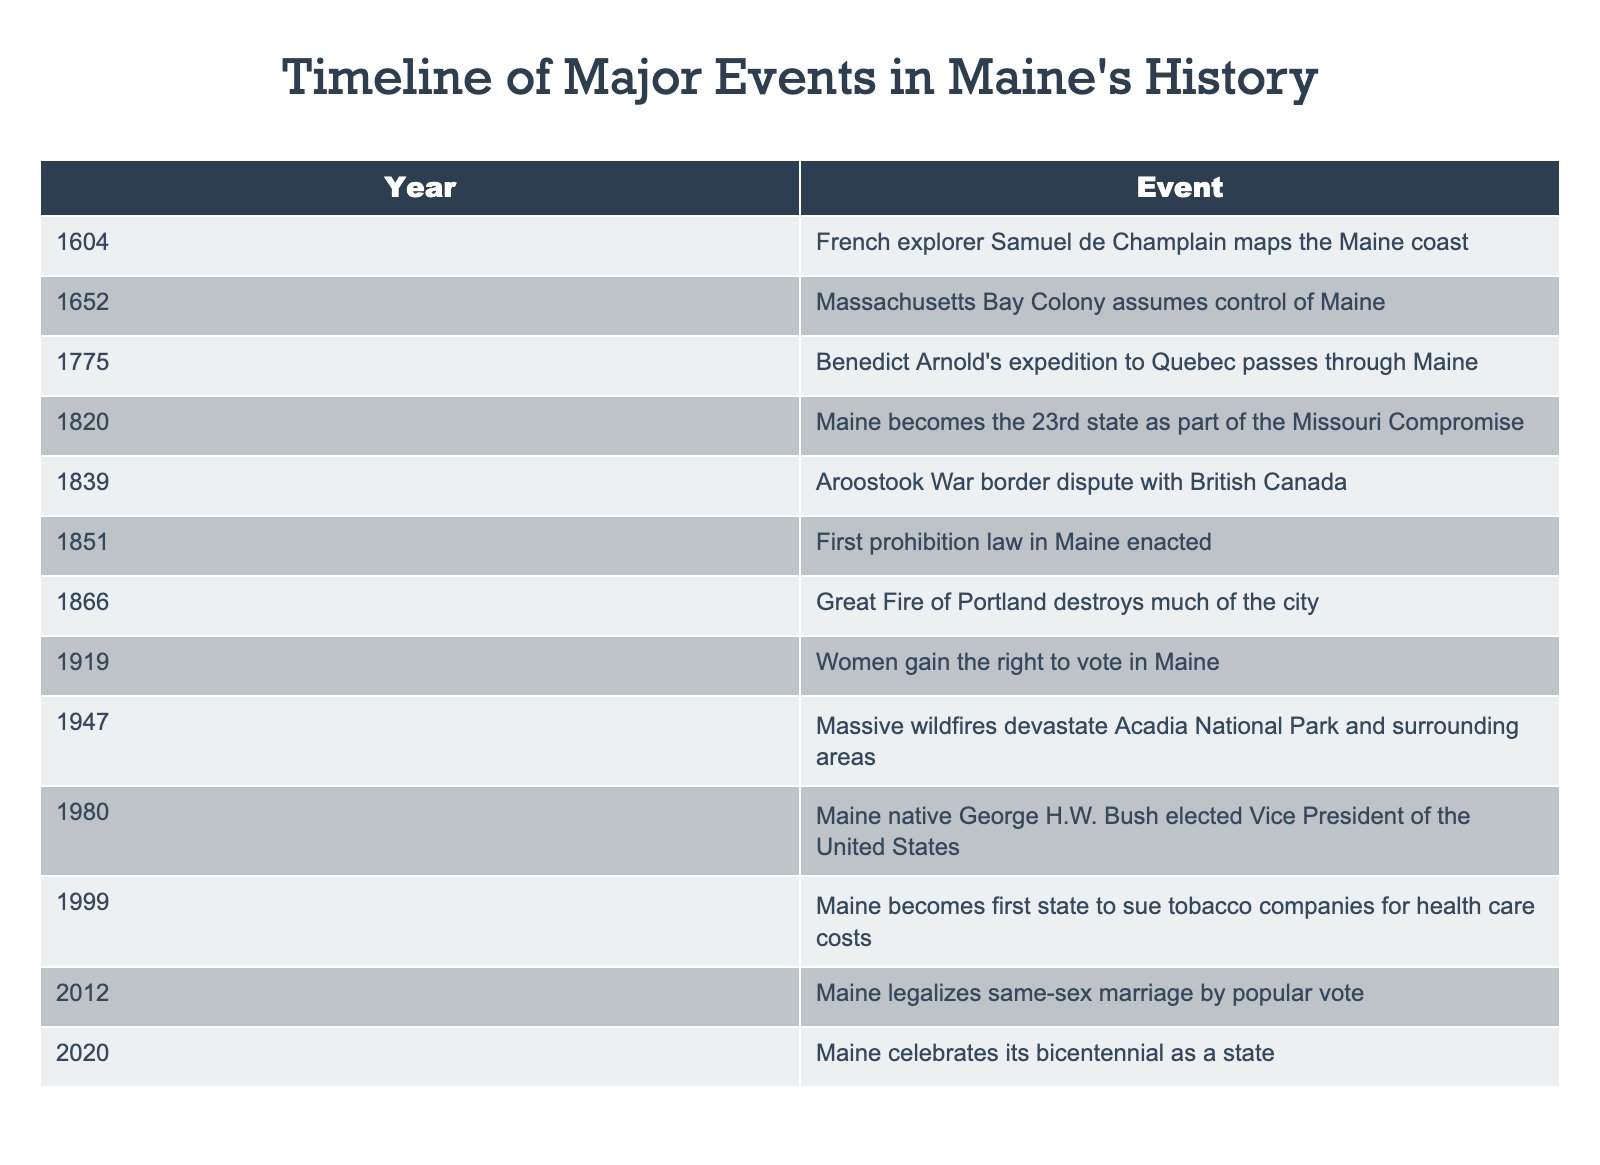What year did Maine become the 23rd state? The table lists "Maine becomes the 23rd state as part of the Missouri Compromise" in the year 1820. Thus, the event is directly referenced next to the year in the table.
Answer: 1820 Which event occurred first: the Great Fire of Portland or women gaining the right to vote in Maine? According to the table, the Great Fire of Portland occurred in 1866 and women gained the right to vote in 1919. By comparing the years, it is clear that the Great Fire of Portland occurred earlier.
Answer: The Great Fire of Portland Was the Aroostook War border dispute with British Canada before or after Maine became a state? The Aroostook War is listed in 1839, while Maine became a state in 1820. Since 1839 is after 1820, the Aroostook War happened after Maine became a state.
Answer: After How many years apart were the enacting of the first prohibition law in Maine and the Great Fire of Portland? The first prohibition law was enacted in 1851 and the Great Fire of Portland occurred in 1866. To find the number of years apart, subtract 1851 from 1866, which equals 15 years.
Answer: 15 years Is it true that Maine legalized same-sex marriage before celebrating its bicentennial? The table indicates that Maine legalized same-sex marriage in 2012 and celebrated its bicentennial in 2020. Since 2012 is earlier than 2020, this statement is true.
Answer: Yes What was the last major event listed in the timeline, and what year did it occur? The timeline ends with "Maine celebrates its bicentennial as a state" occurring in 2020. This can be verified by looking at the last entry in the table.
Answer: 2020 Which two events occurred in the 20th century according to the table? The events listed in the table for the 20th century are "Women gain the right to vote in Maine" in 1919 and "Massive wildfires devastate Acadia National Park and surrounding areas" in 1947. Both events can be located by their respective years in the table.
Answer: Women gain the right to vote in Maine and Massive wildfires devastate Acadia National Park What percentage of events in the table occurred before the 1900s? There are 12 events listed in total. Counting the events that occurred before 1900 gives us 8 events (from 1604 to 1866). To find the percentage, we take (8/12) * 100, which equals approximately 66.67%.
Answer: Approximately 66.67% 